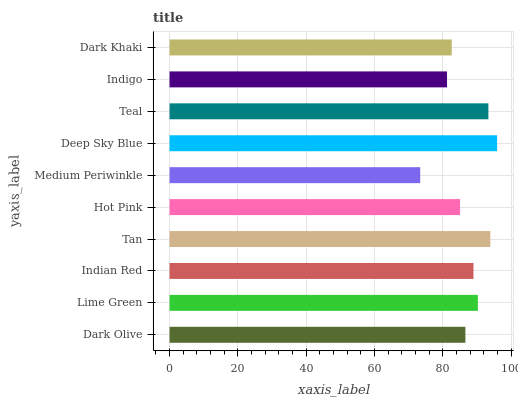Is Medium Periwinkle the minimum?
Answer yes or no. Yes. Is Deep Sky Blue the maximum?
Answer yes or no. Yes. Is Lime Green the minimum?
Answer yes or no. No. Is Lime Green the maximum?
Answer yes or no. No. Is Lime Green greater than Dark Olive?
Answer yes or no. Yes. Is Dark Olive less than Lime Green?
Answer yes or no. Yes. Is Dark Olive greater than Lime Green?
Answer yes or no. No. Is Lime Green less than Dark Olive?
Answer yes or no. No. Is Indian Red the high median?
Answer yes or no. Yes. Is Dark Olive the low median?
Answer yes or no. Yes. Is Tan the high median?
Answer yes or no. No. Is Indian Red the low median?
Answer yes or no. No. 